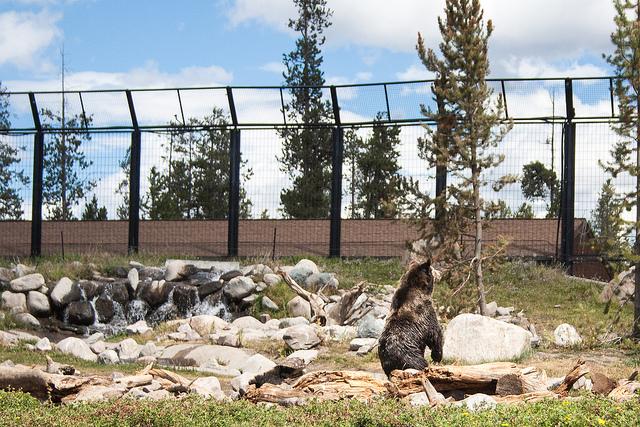What time of day is it?
Quick response, please. Noon. Is the animal standing on its hind legs?
Quick response, please. Yes. Is the sky cloudy at all?
Quick response, please. Yes. What animal is this?
Quick response, please. Bear. 